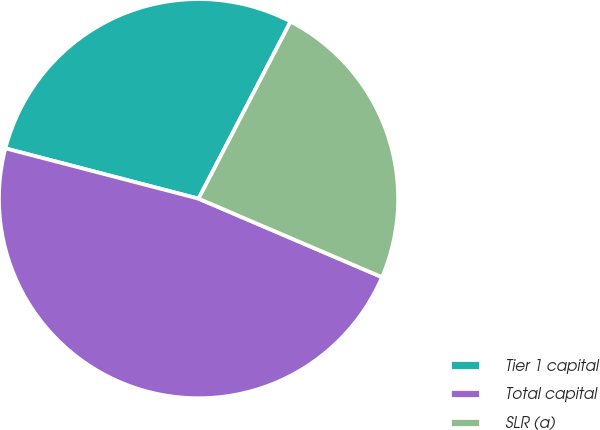<chart> <loc_0><loc_0><loc_500><loc_500><pie_chart><fcel>Tier 1 capital<fcel>Total capital<fcel>SLR (a)<nl><fcel>28.57%<fcel>47.62%<fcel>23.81%<nl></chart> 